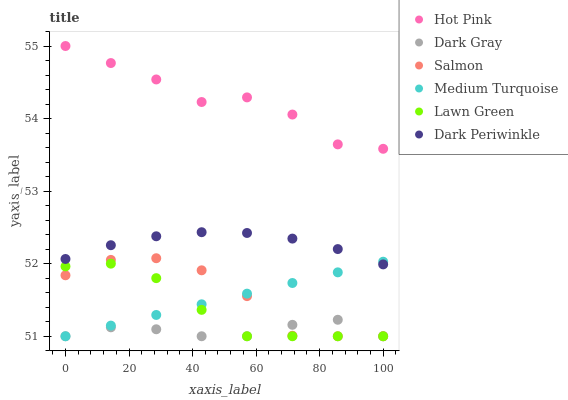Does Dark Gray have the minimum area under the curve?
Answer yes or no. Yes. Does Hot Pink have the maximum area under the curve?
Answer yes or no. Yes. Does Salmon have the minimum area under the curve?
Answer yes or no. No. Does Salmon have the maximum area under the curve?
Answer yes or no. No. Is Medium Turquoise the smoothest?
Answer yes or no. Yes. Is Salmon the roughest?
Answer yes or no. Yes. Is Hot Pink the smoothest?
Answer yes or no. No. Is Hot Pink the roughest?
Answer yes or no. No. Does Lawn Green have the lowest value?
Answer yes or no. Yes. Does Hot Pink have the lowest value?
Answer yes or no. No. Does Hot Pink have the highest value?
Answer yes or no. Yes. Does Salmon have the highest value?
Answer yes or no. No. Is Salmon less than Hot Pink?
Answer yes or no. Yes. Is Hot Pink greater than Lawn Green?
Answer yes or no. Yes. Does Medium Turquoise intersect Lawn Green?
Answer yes or no. Yes. Is Medium Turquoise less than Lawn Green?
Answer yes or no. No. Is Medium Turquoise greater than Lawn Green?
Answer yes or no. No. Does Salmon intersect Hot Pink?
Answer yes or no. No. 